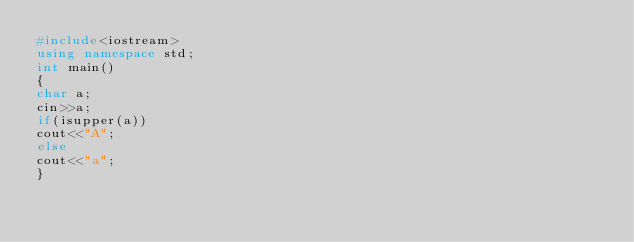<code> <loc_0><loc_0><loc_500><loc_500><_C++_>#include<iostream>
using namespace std;
int main()
{
char a;
cin>>a;
if(isupper(a))
cout<<"A";
else
cout<<"a";
}</code> 